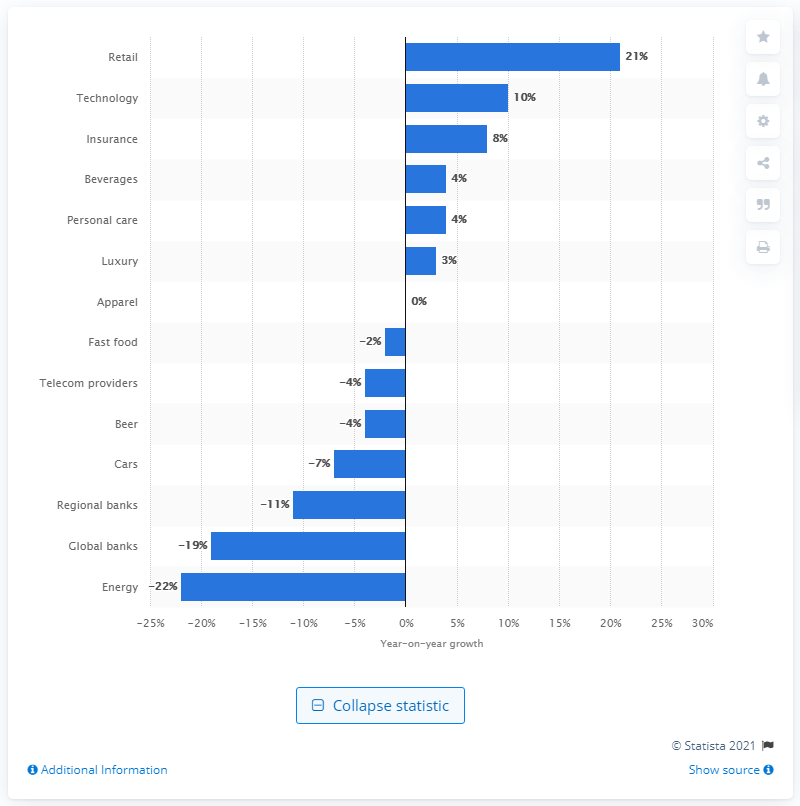List a handful of essential elements in this visual. The brand value growth of the retail sector in 2020 was significant. 